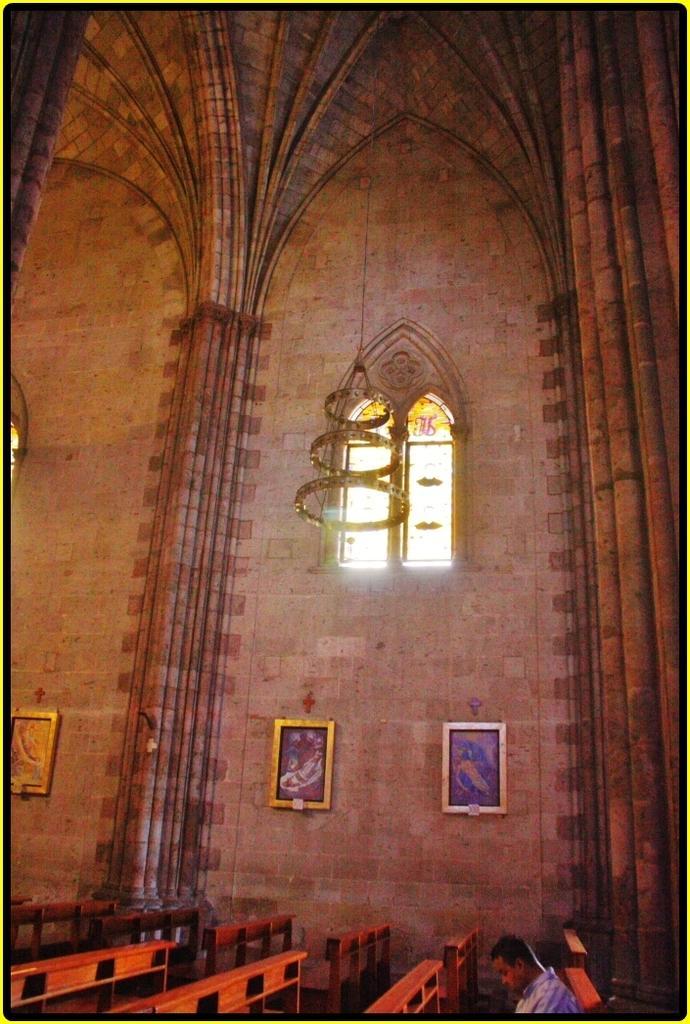Can you describe this image briefly? In this image there are some tables in the bottom of this image. there is one person sitting on to this table in the bottom right corner of this image. There is a wall in the background. There are some photo frames attached on it. There is a window on the top of this image. 